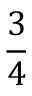Convert formula to latex. <formula><loc_0><loc_0><loc_500><loc_500>\frac { 3 } { 4 }</formula> 